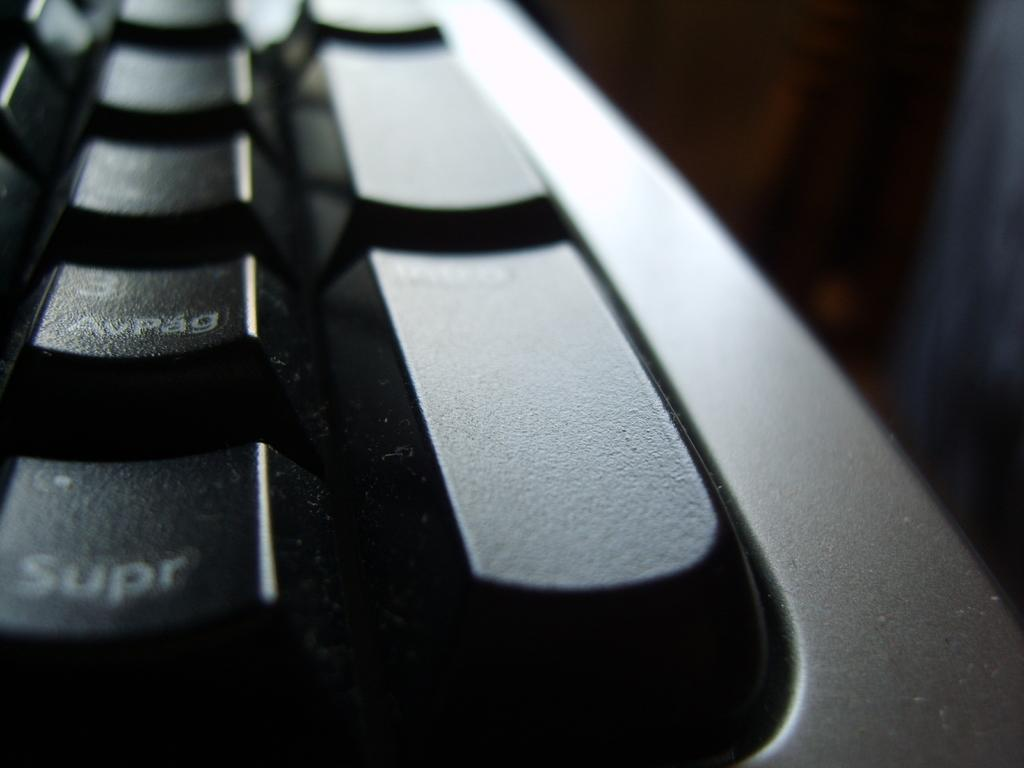What type of device is visible in the image? There is a black keyboard with keys in the image. Can you describe the right side of the image? The right side of the image has a blurred view. What type of science experiment is being conducted with steam in the image? There is no science experiment or steam present in the image; it only features a black keyboard with keys and a blurred view on the right side. 